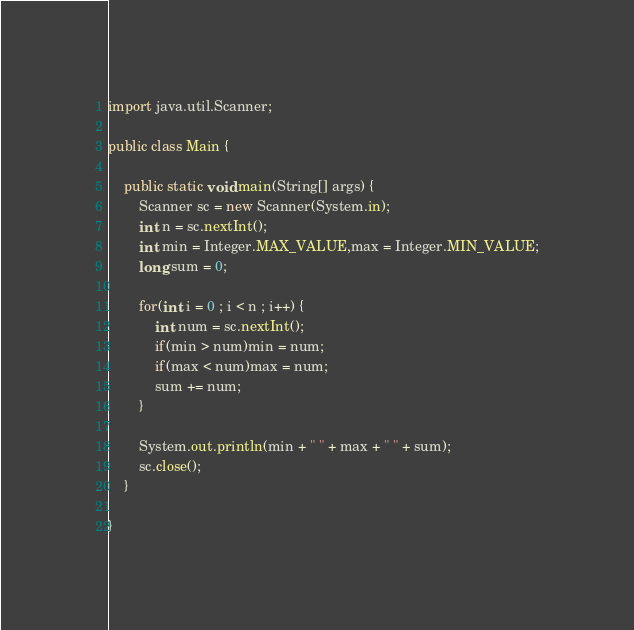<code> <loc_0><loc_0><loc_500><loc_500><_Java_>import java.util.Scanner;

public class Main {

	public static void main(String[] args) {
        Scanner sc = new Scanner(System.in);
        int n = sc.nextInt();
        int min = Integer.MAX_VALUE,max = Integer.MIN_VALUE;
        long sum = 0;

        for(int i = 0 ; i < n ; i++) {
        	int num = sc.nextInt();
        	if(min > num)min = num;
        	if(max < num)max = num;
        	sum += num;
        }

        System.out.println(min + " " + max + " " + sum);
        sc.close();
	}

}

</code> 